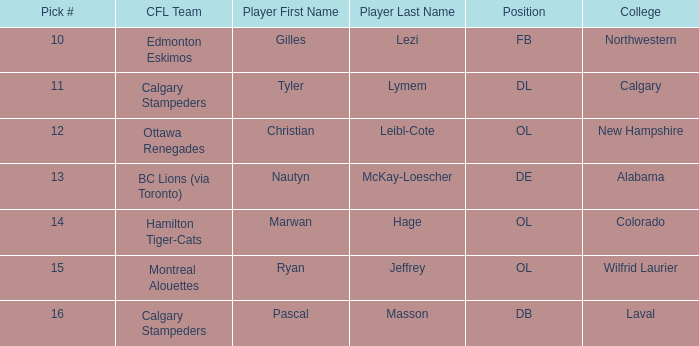What position does Christian Leibl-Cote play? OL. 